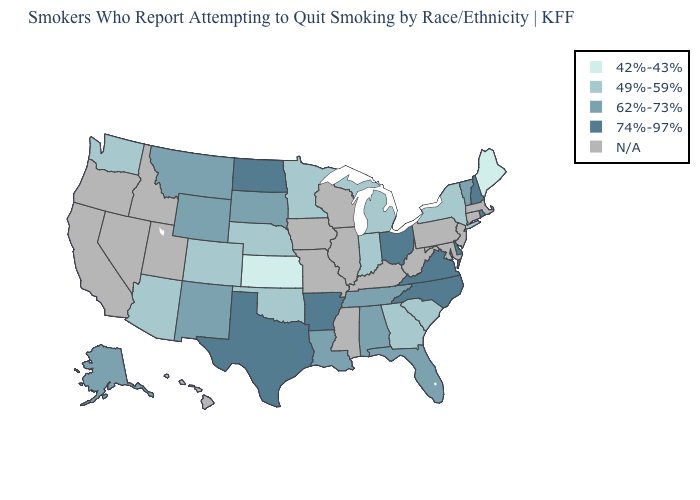What is the lowest value in the USA?
Answer briefly. 42%-43%. What is the highest value in the MidWest ?
Write a very short answer. 74%-97%. What is the lowest value in the USA?
Short answer required. 42%-43%. What is the value of Kansas?
Be succinct. 42%-43%. Name the states that have a value in the range 62%-73%?
Quick response, please. Alabama, Alaska, Florida, Louisiana, Montana, New Mexico, South Dakota, Tennessee, Vermont, Wyoming. What is the value of Missouri?
Give a very brief answer. N/A. Is the legend a continuous bar?
Be succinct. No. Which states have the lowest value in the USA?
Keep it brief. Kansas, Maine. What is the highest value in states that border Maine?
Answer briefly. 74%-97%. Name the states that have a value in the range 42%-43%?
Answer briefly. Kansas, Maine. What is the value of South Dakota?
Quick response, please. 62%-73%. What is the highest value in the USA?
Answer briefly. 74%-97%. What is the value of Virginia?
Quick response, please. 74%-97%. Which states have the lowest value in the MidWest?
Short answer required. Kansas. 